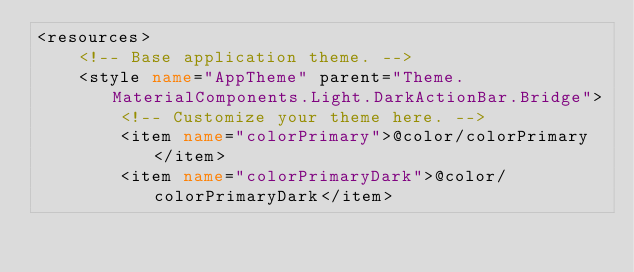<code> <loc_0><loc_0><loc_500><loc_500><_XML_><resources>
    <!-- Base application theme. -->
    <style name="AppTheme" parent="Theme.MaterialComponents.Light.DarkActionBar.Bridge">
        <!-- Customize your theme here. -->
        <item name="colorPrimary">@color/colorPrimary</item>
        <item name="colorPrimaryDark">@color/colorPrimaryDark</item></code> 